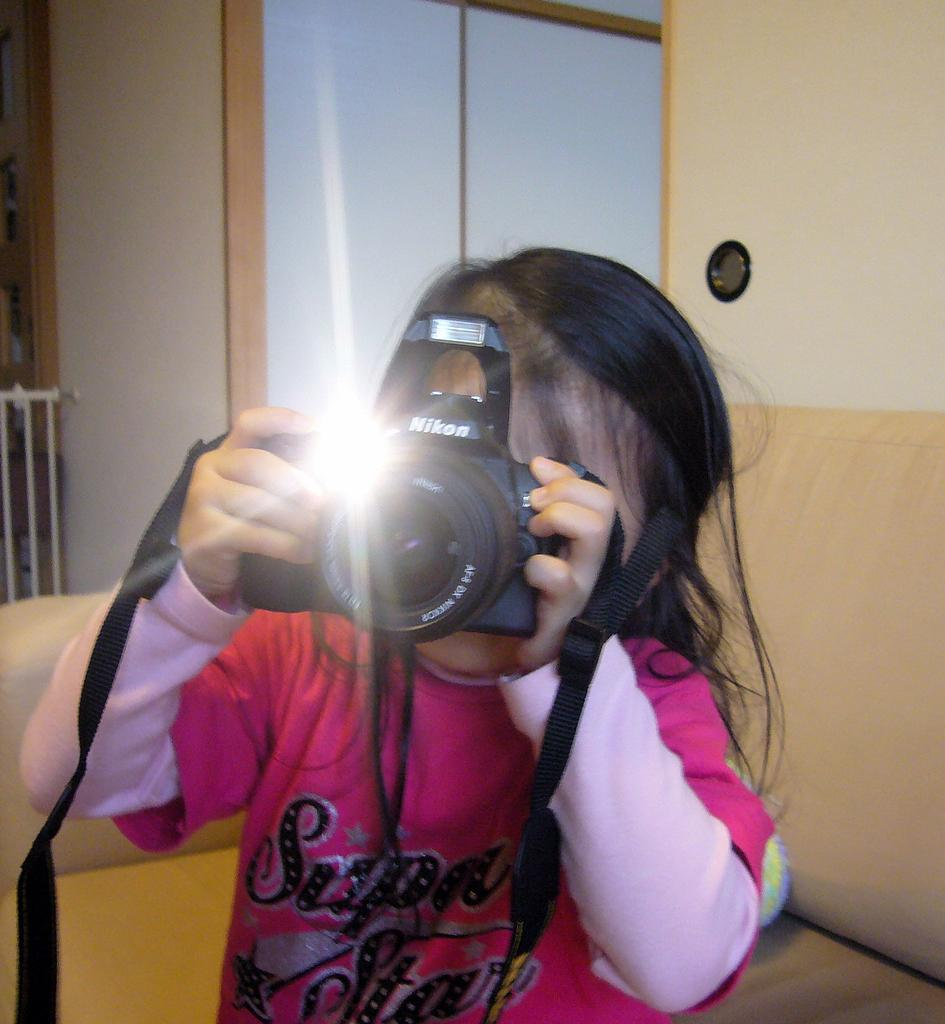Who is the main subject in the image? There is a girl in the image. What is the girl holding in the image? The girl is holding a camera. What piece of furniture is present in the image? There is a sofa in the image. What type of leather is used to make the bed in the image? There is no bed present in the image, so it is not possible to determine the type of leather used. 